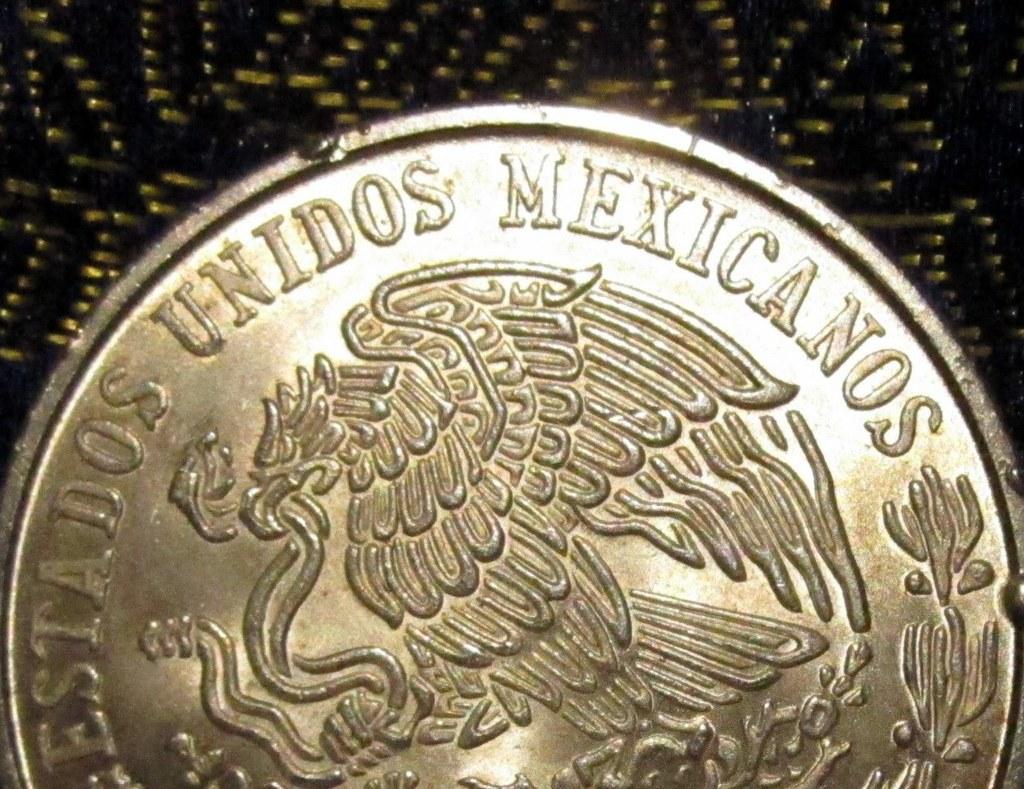What is the word in the middle of the coin?
Your answer should be very brief. Unidos. Is this current mexican currency?
Provide a succinct answer. Yes. 